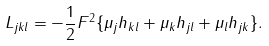Convert formula to latex. <formula><loc_0><loc_0><loc_500><loc_500>L _ { j k l } = - \frac { 1 } { 2 } F ^ { 2 } \{ \mu _ { j } h _ { k l } + \mu _ { k } h _ { j l } + \mu _ { l } h _ { j k } \} .</formula> 